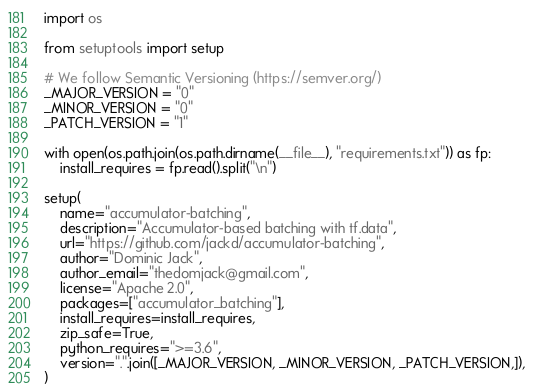Convert code to text. <code><loc_0><loc_0><loc_500><loc_500><_Python_>import os

from setuptools import setup

# We follow Semantic Versioning (https://semver.org/)
_MAJOR_VERSION = "0"
_MINOR_VERSION = "0"
_PATCH_VERSION = "1"

with open(os.path.join(os.path.dirname(__file__), "requirements.txt")) as fp:
    install_requires = fp.read().split("\n")

setup(
    name="accumulator-batching",
    description="Accumulator-based batching with tf.data",
    url="https://github.com/jackd/accumulator-batching",
    author="Dominic Jack",
    author_email="thedomjack@gmail.com",
    license="Apache 2.0",
    packages=["accumulator_batching"],
    install_requires=install_requires,
    zip_safe=True,
    python_requires=">=3.6",
    version=".".join([_MAJOR_VERSION, _MINOR_VERSION, _PATCH_VERSION,]),
)
</code> 